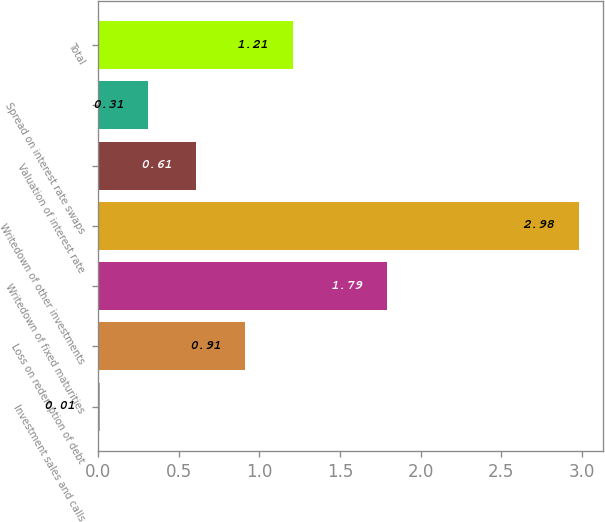Convert chart to OTSL. <chart><loc_0><loc_0><loc_500><loc_500><bar_chart><fcel>Investment sales and calls<fcel>Loss on redemption of debt<fcel>Writedown of fixed maturities<fcel>Writedown of other investments<fcel>Valuation of interest rate<fcel>Spread on interest rate swaps<fcel>Total<nl><fcel>0.01<fcel>0.91<fcel>1.79<fcel>2.98<fcel>0.61<fcel>0.31<fcel>1.21<nl></chart> 